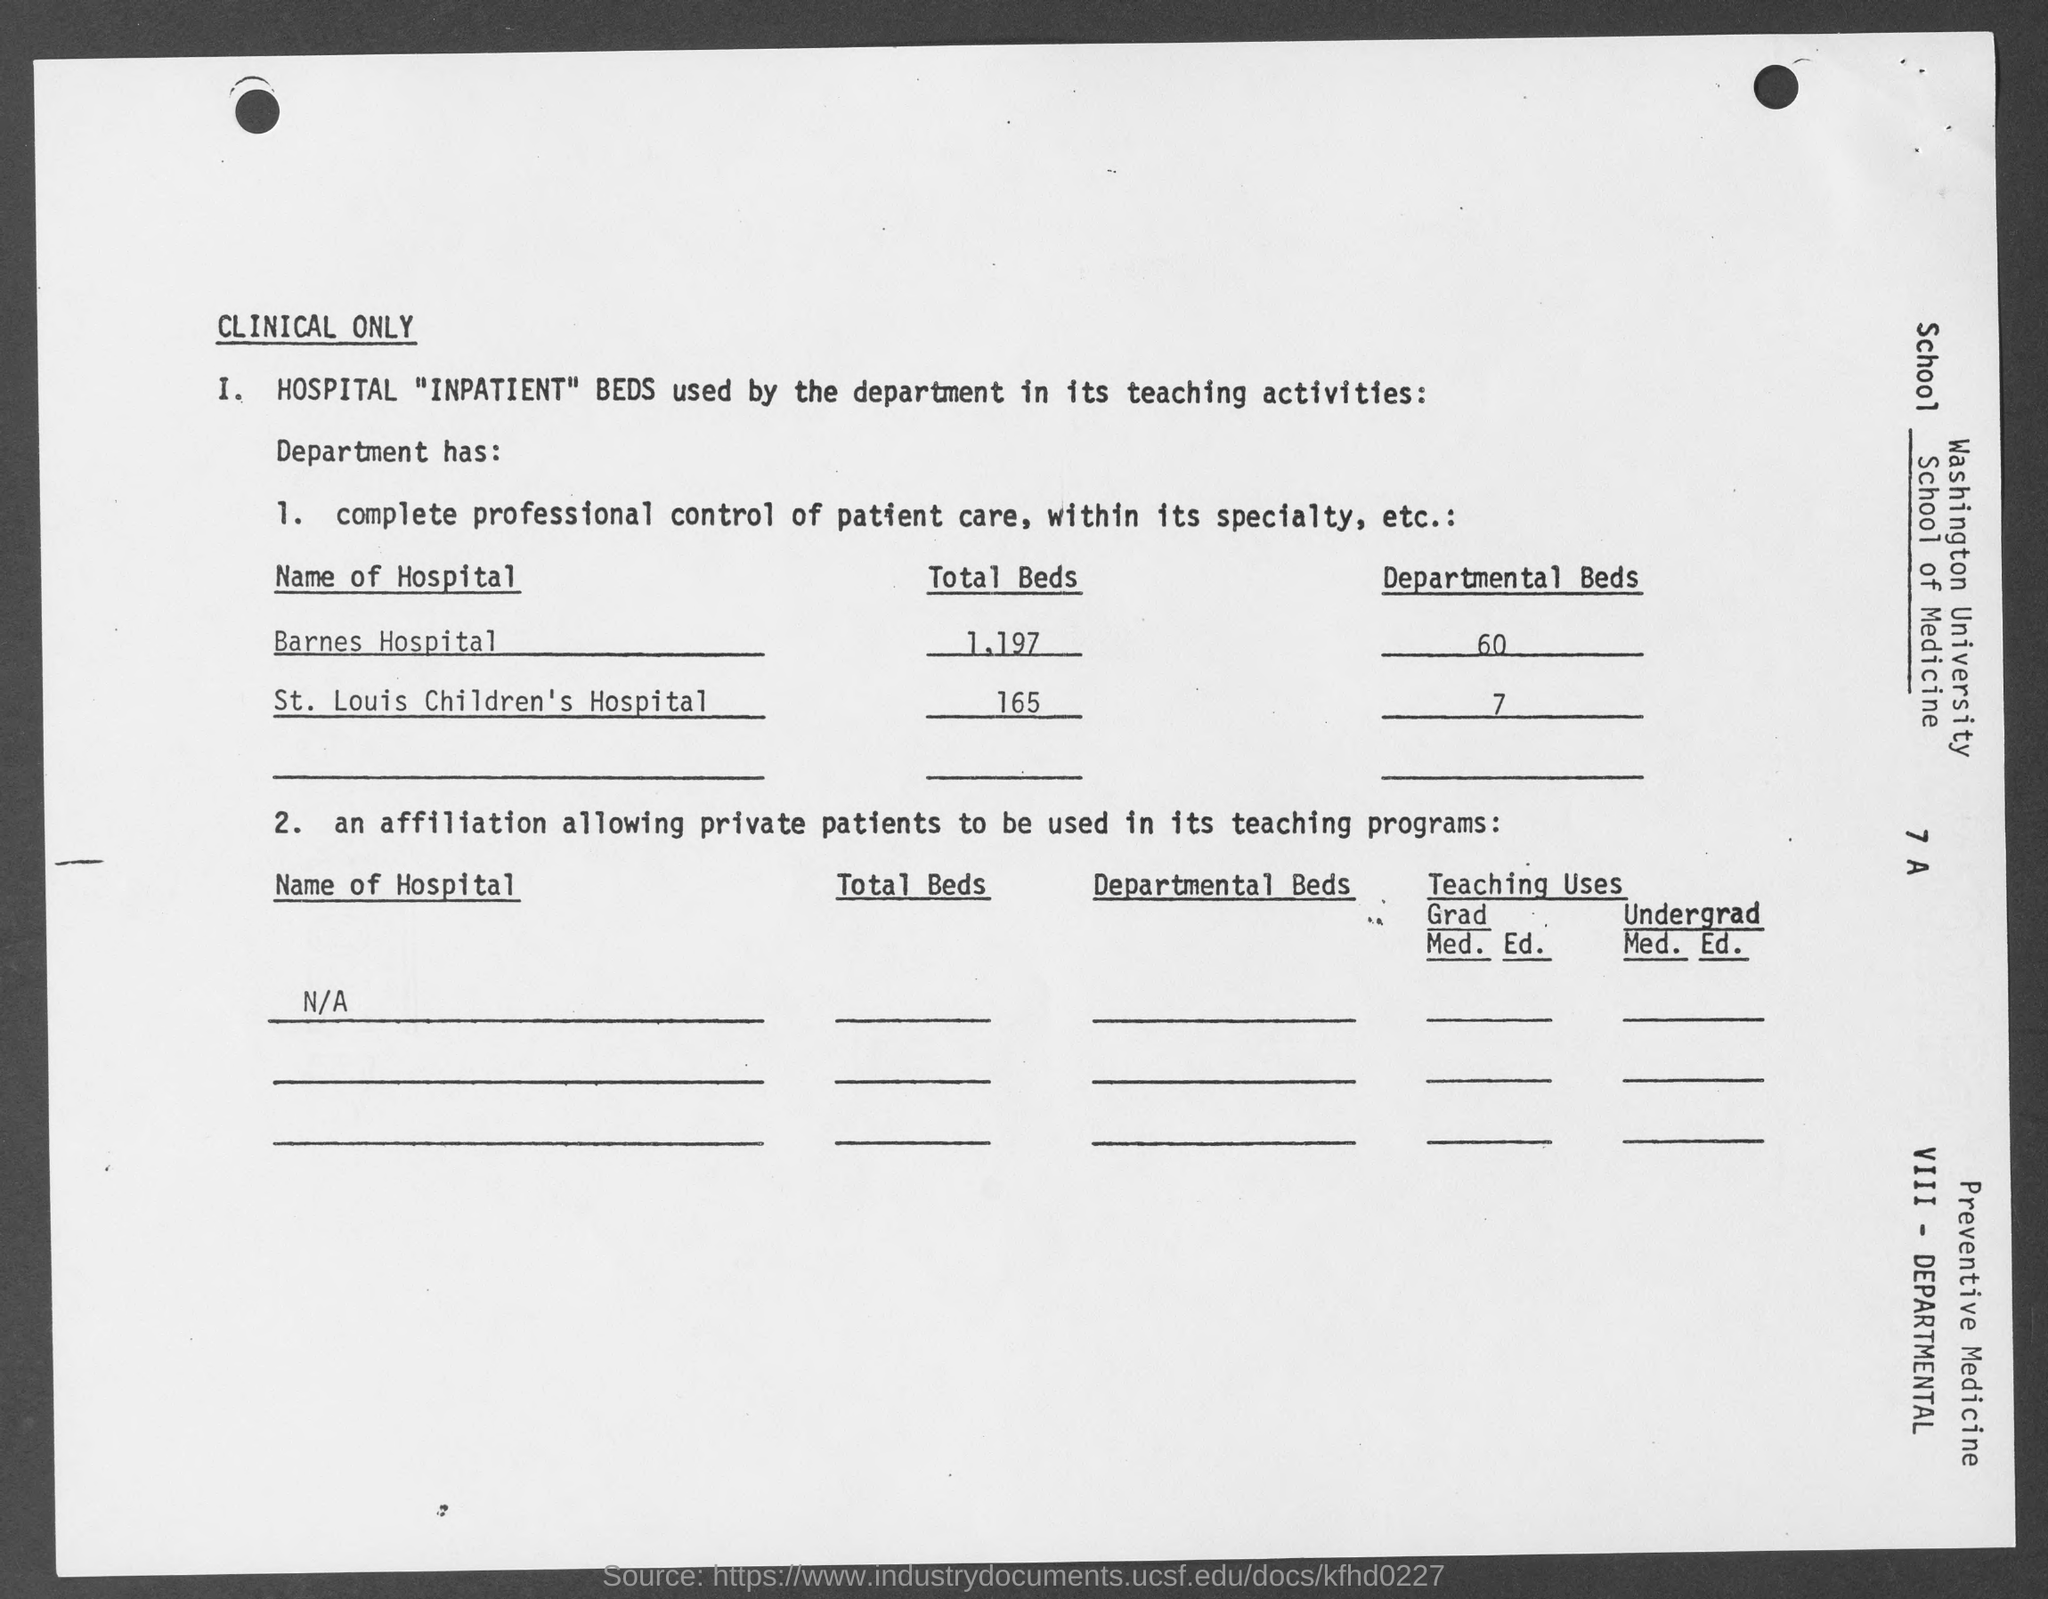Draw attention to some important aspects in this diagram. The total number of beds at St. Louis Children's Hospital is 165. Barnes Hospital has a total of 1,197 beds. There are currently 7 departmental beds available at St. Louis Children's Hospital. There are currently 60 departmental beds available at Barnes Hospital. 